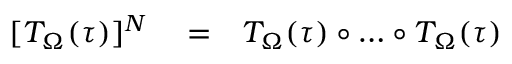<formula> <loc_0><loc_0><loc_500><loc_500>\begin{array} { r l r } { [ T _ { \Omega } ( \tau ) ] ^ { N } } & = } & { T _ { \Omega } ( \tau ) \circ \dots \circ T _ { \Omega } ( \tau ) } \end{array}</formula> 